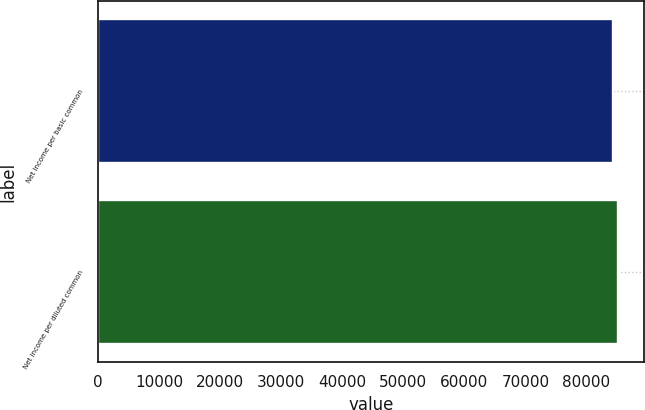Convert chart. <chart><loc_0><loc_0><loc_500><loc_500><bar_chart><fcel>Net income per basic common<fcel>Net income per diluted common<nl><fcel>84358<fcel>85151<nl></chart> 